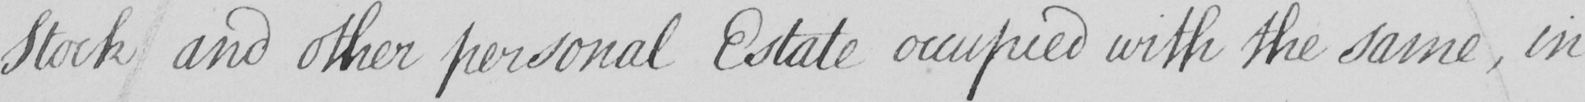Please transcribe the handwritten text in this image. Stock and other personal Estate occupied with the same , in 